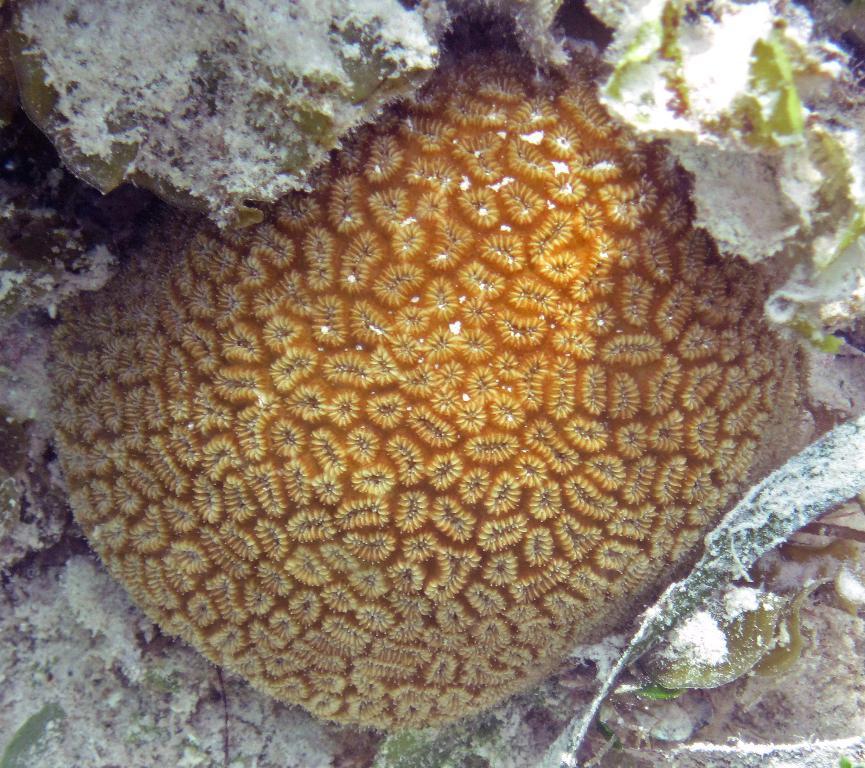In one or two sentences, can you explain what this image depicts? This picture describes about underwater environment. 